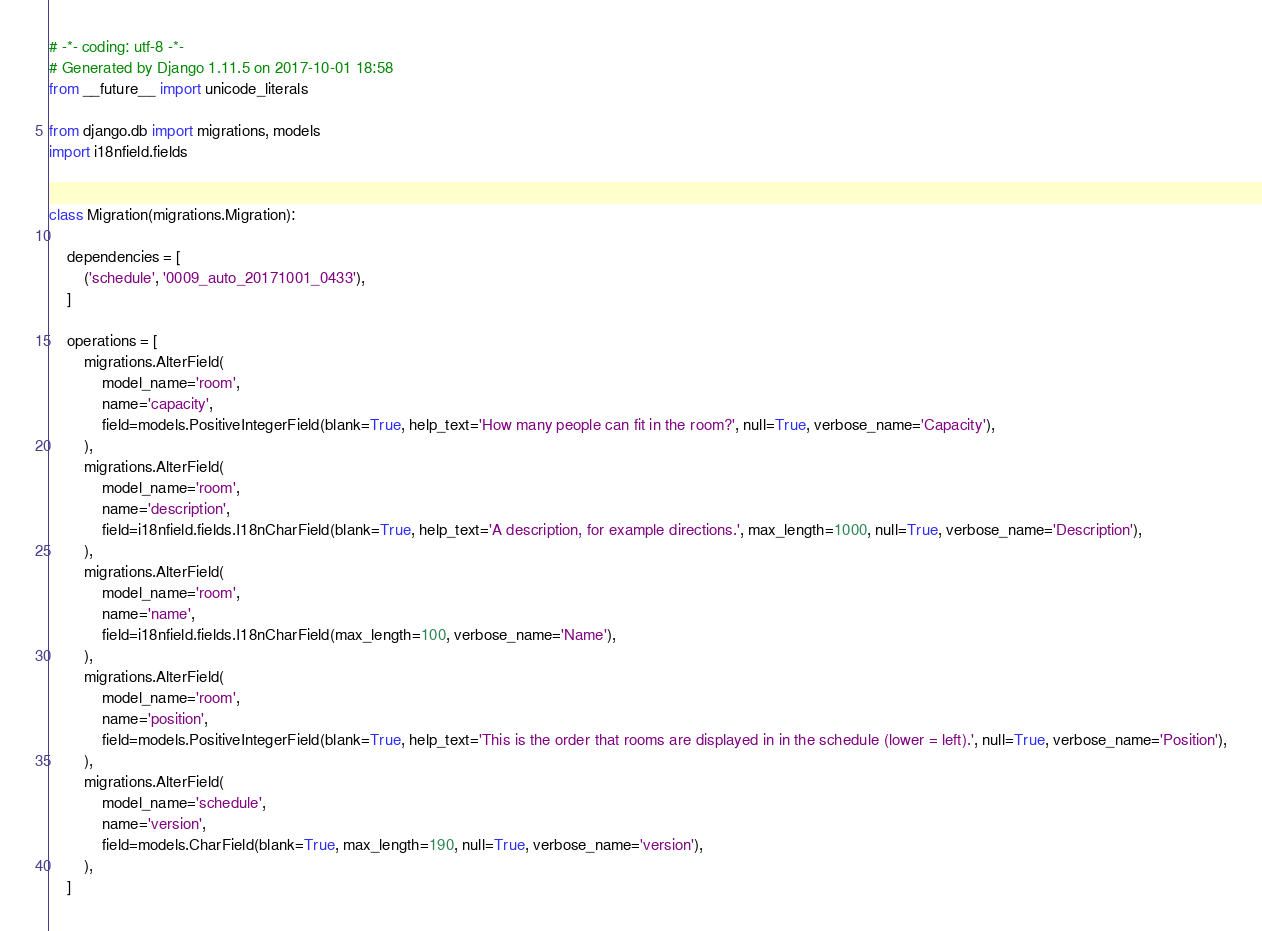<code> <loc_0><loc_0><loc_500><loc_500><_Python_># -*- coding: utf-8 -*-
# Generated by Django 1.11.5 on 2017-10-01 18:58
from __future__ import unicode_literals

from django.db import migrations, models
import i18nfield.fields


class Migration(migrations.Migration):

    dependencies = [
        ('schedule', '0009_auto_20171001_0433'),
    ]

    operations = [
        migrations.AlterField(
            model_name='room',
            name='capacity',
            field=models.PositiveIntegerField(blank=True, help_text='How many people can fit in the room?', null=True, verbose_name='Capacity'),
        ),
        migrations.AlterField(
            model_name='room',
            name='description',
            field=i18nfield.fields.I18nCharField(blank=True, help_text='A description, for example directions.', max_length=1000, null=True, verbose_name='Description'),
        ),
        migrations.AlterField(
            model_name='room',
            name='name',
            field=i18nfield.fields.I18nCharField(max_length=100, verbose_name='Name'),
        ),
        migrations.AlterField(
            model_name='room',
            name='position',
            field=models.PositiveIntegerField(blank=True, help_text='This is the order that rooms are displayed in in the schedule (lower = left).', null=True, verbose_name='Position'),
        ),
        migrations.AlterField(
            model_name='schedule',
            name='version',
            field=models.CharField(blank=True, max_length=190, null=True, verbose_name='version'),
        ),
    ]
</code> 